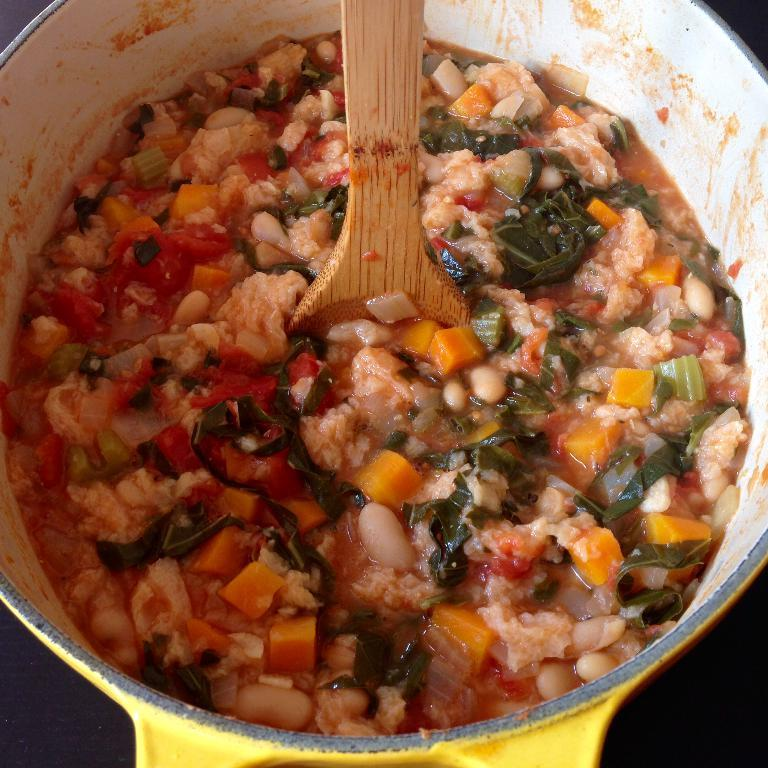What type of food item can be seen in the image? There is a food item made of vegetables in the image. How is the food item being stored or displayed? The food item is kept in a yellow-colored pan. What role does the army play in the destruction of the food item in the image? There is no army or destruction present in the image; it only features a food item made of vegetables in a yellow-colored pan. 